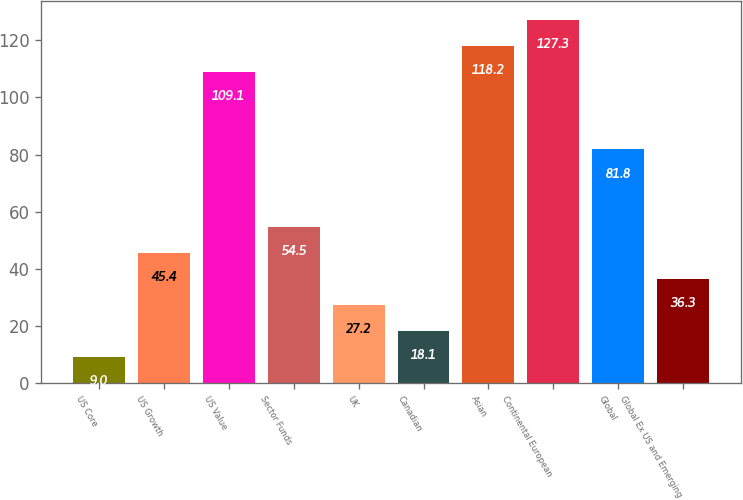<chart> <loc_0><loc_0><loc_500><loc_500><bar_chart><fcel>US Core<fcel>US Growth<fcel>US Value<fcel>Sector Funds<fcel>UK<fcel>Canadian<fcel>Asian<fcel>Continental European<fcel>Global<fcel>Global Ex US and Emerging<nl><fcel>9<fcel>45.4<fcel>109.1<fcel>54.5<fcel>27.2<fcel>18.1<fcel>118.2<fcel>127.3<fcel>81.8<fcel>36.3<nl></chart> 